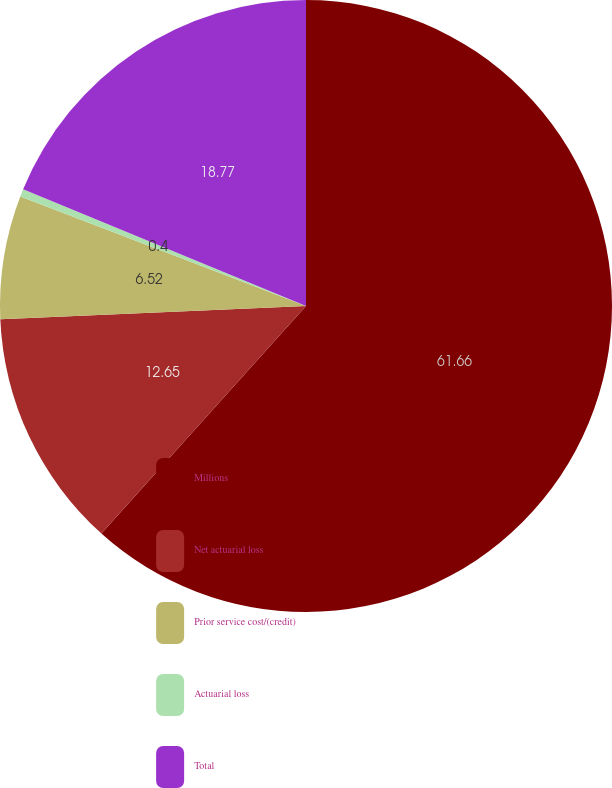<chart> <loc_0><loc_0><loc_500><loc_500><pie_chart><fcel>Millions<fcel>Net actuarial loss<fcel>Prior service cost/(credit)<fcel>Actuarial loss<fcel>Total<nl><fcel>61.65%<fcel>12.65%<fcel>6.52%<fcel>0.4%<fcel>18.77%<nl></chart> 